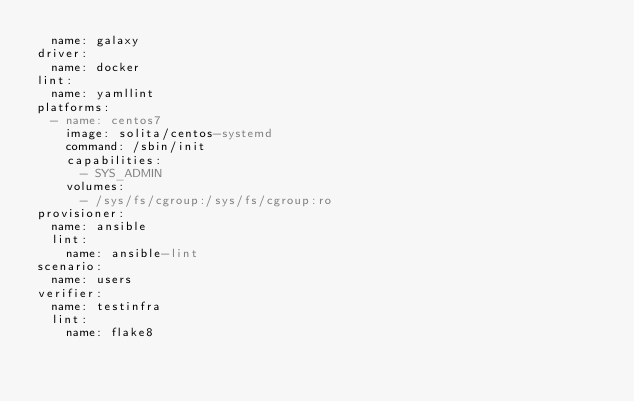Convert code to text. <code><loc_0><loc_0><loc_500><loc_500><_YAML_>  name: galaxy
driver:
  name: docker
lint:
  name: yamllint
platforms:
  - name: centos7
    image: solita/centos-systemd
    command: /sbin/init
    capabilities:
      - SYS_ADMIN
    volumes:
      - /sys/fs/cgroup:/sys/fs/cgroup:ro
provisioner:
  name: ansible
  lint:
    name: ansible-lint
scenario:
  name: users
verifier:
  name: testinfra
  lint:
    name: flake8
</code> 